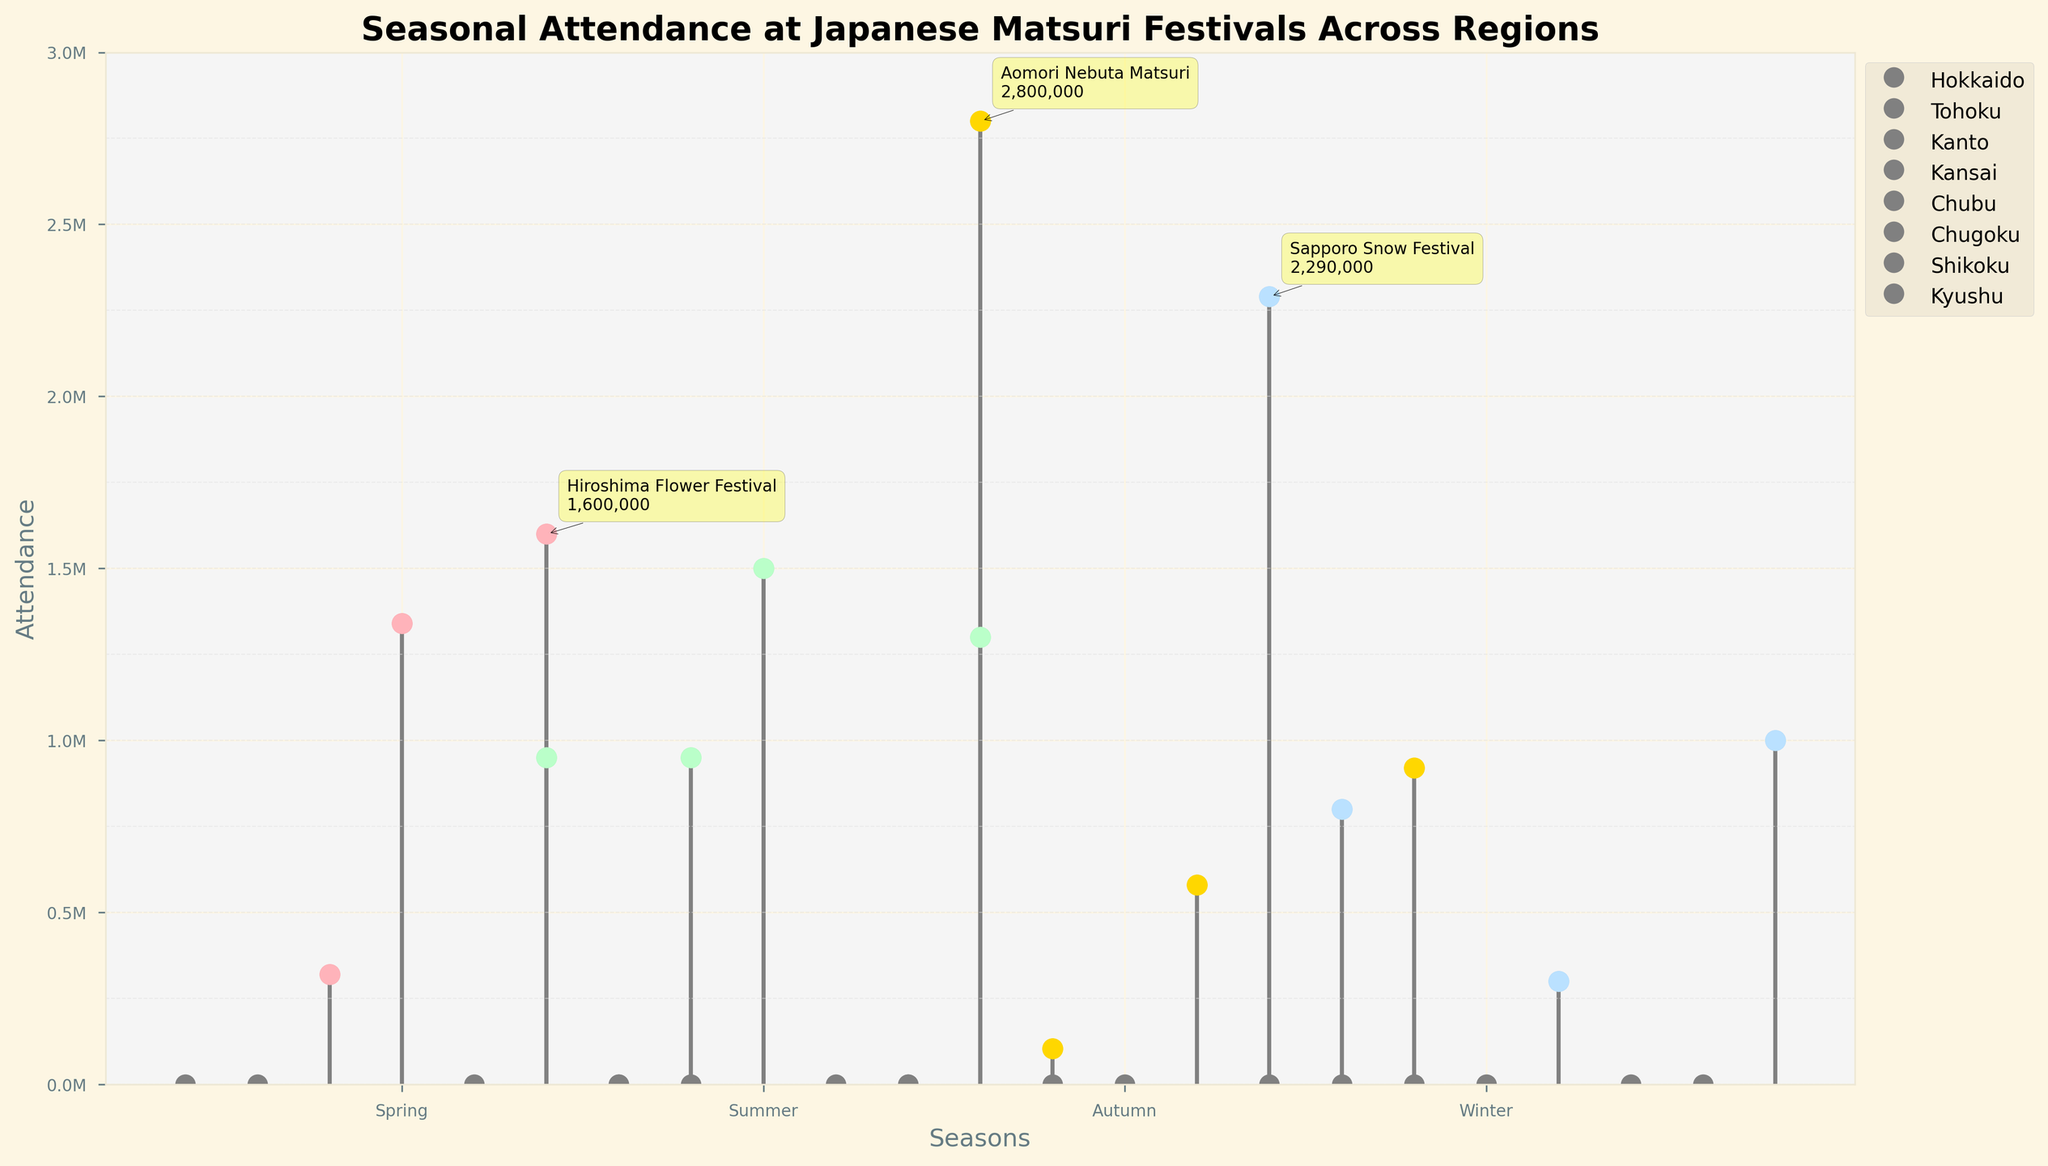What is the title of the figure? The title of the figure is generally displayed at the top of the plot and communicates the main topic of the visualization. By looking at the top of the plot, you can read the title.
Answer: Seasonal Attendance at Japanese Matsuri Festivals Across Regions How is the attendance data visually represented for different seasons and regions? In the stem plot, each region's attendance data is represented by lines extending from a baseline to a marker, with colors representing different seasons. The markers are colored differently according to the season (Spring, Summer, Autumn, Winter).
Answer: Lines and colored markers Which region hosts the Sapporo Snow Festival, and in which season does this festival occur? Look at the annotation and color-coded markers in the plot. The Sapporo Snow Festival is hosted in Hokkaido during the Winter season, which is represented in blue markers.
Answer: Hokkaido, Winter What is the attendance of the Sumida River Fireworks Festival in the Kanto region during Summer? Find the marker corresponding to the Kanto region in the Summer cluster. By looking at the vertical line and the annotation (if available), the attendance of the Sumida River Fireworks Festival is around 950,000.
Answer: 950,000 Which season has the highest average attendance across all regions? Calculate the average attendance for each season by summing the attendance figures and dividing by the number of festivals held in each season, based on their color-coded markers. Select the season with the highest average value.
Answer: Summer (approx. 1,137,500 average) Which region has the most festivals listed, and how many are there? Count the number of markers (data points) for each region on the plot. The region with the highest count of festivals is the one with the most markers.
Answer: Hokkaido (2 festivals) Compare the attendance of the Aomori Nebuta Matsuri in Tohoku with the Hakodate Port Festival in Hokkaido. Which has higher attendance? Locate the markers for Aomori Nebuta Matsuri (Tohoku, Autumn) and Hakodate Port Festival (Hokkaido, Summer). Compare the vertical heights of the markers or look at the annotations for their attendance figures directly.
Answer: Aomori Nebuta Matsuri What is the combined attendance of the top 3 festivals? Identify the festivals with the largest markers (annotations usually help). Add their attendance figures together. The top 3 festivals are Sapporo Snow Festival (2,290,000), Aomori Nebuta Matsuri (2,800,000), and Tenjin Matsuri (1,500,000). Add these figures: 2,290,000 + 2,800,000 + 1,500,000.
Answer: 6,590,000 What is the difference in attendance between the Hiroshima Flower Festival and the Takayama Matsuri? Locate the markers for Hiroshima Flower Festival (Chugoku, Spring) and Takayama Matsuri (Chubu, Winter). Subtract the attendance of Takayama Matsuri from that of Hiroshima Flower Festival: 1,600,000 - 300,000 = 1,300,000.
Answer: 1,300,000 